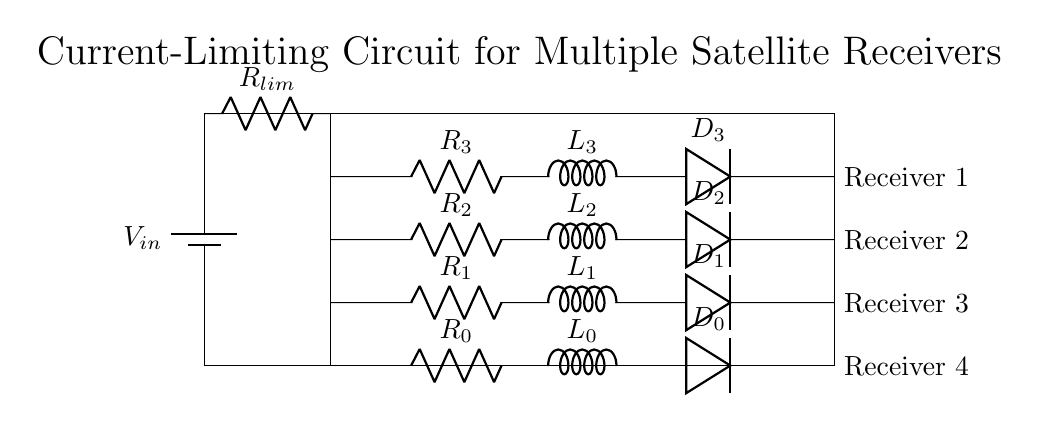What is the type of circuit shown? The circuit is a parallel circuit since it has multiple branches connecting to the same two nodes, allowing current to split among them.
Answer: Parallel How many satellite receivers are there? The diagram shows four satellite receivers, each connected to a separate branch of the circuit.
Answer: Four What is the role of the resistor labeled R limiting? The resistor labeled R limiting serves to limit the current flowing into the branches of the circuit, preventing excessive current to each receiver.
Answer: Limit current What is the purpose of the inductor in each branch? The inductor in each branch acts to filter or smooth out voltage fluctuations, helping to maintain stable operation for each receiver.
Answer: Filter voltage If one receiver is removed, how does this affect the others? Removing one receiver still allows the others to function normally, which is characteristic of parallel circuits where each branch operates independently.
Answer: Others unaffected What component connects the branches to the power supply? The component connecting the branches to the power supply is the current-limiting resistor, which feeds current into the branches while controlling the total current flowing from the supply.
Answer: Current-limiting resistor What do the components labeled D represent? The components labeled D in the diagram represent diodes, which allow current to flow in one direction only, providing protection to the receivers from reverse current.
Answer: Diodes 